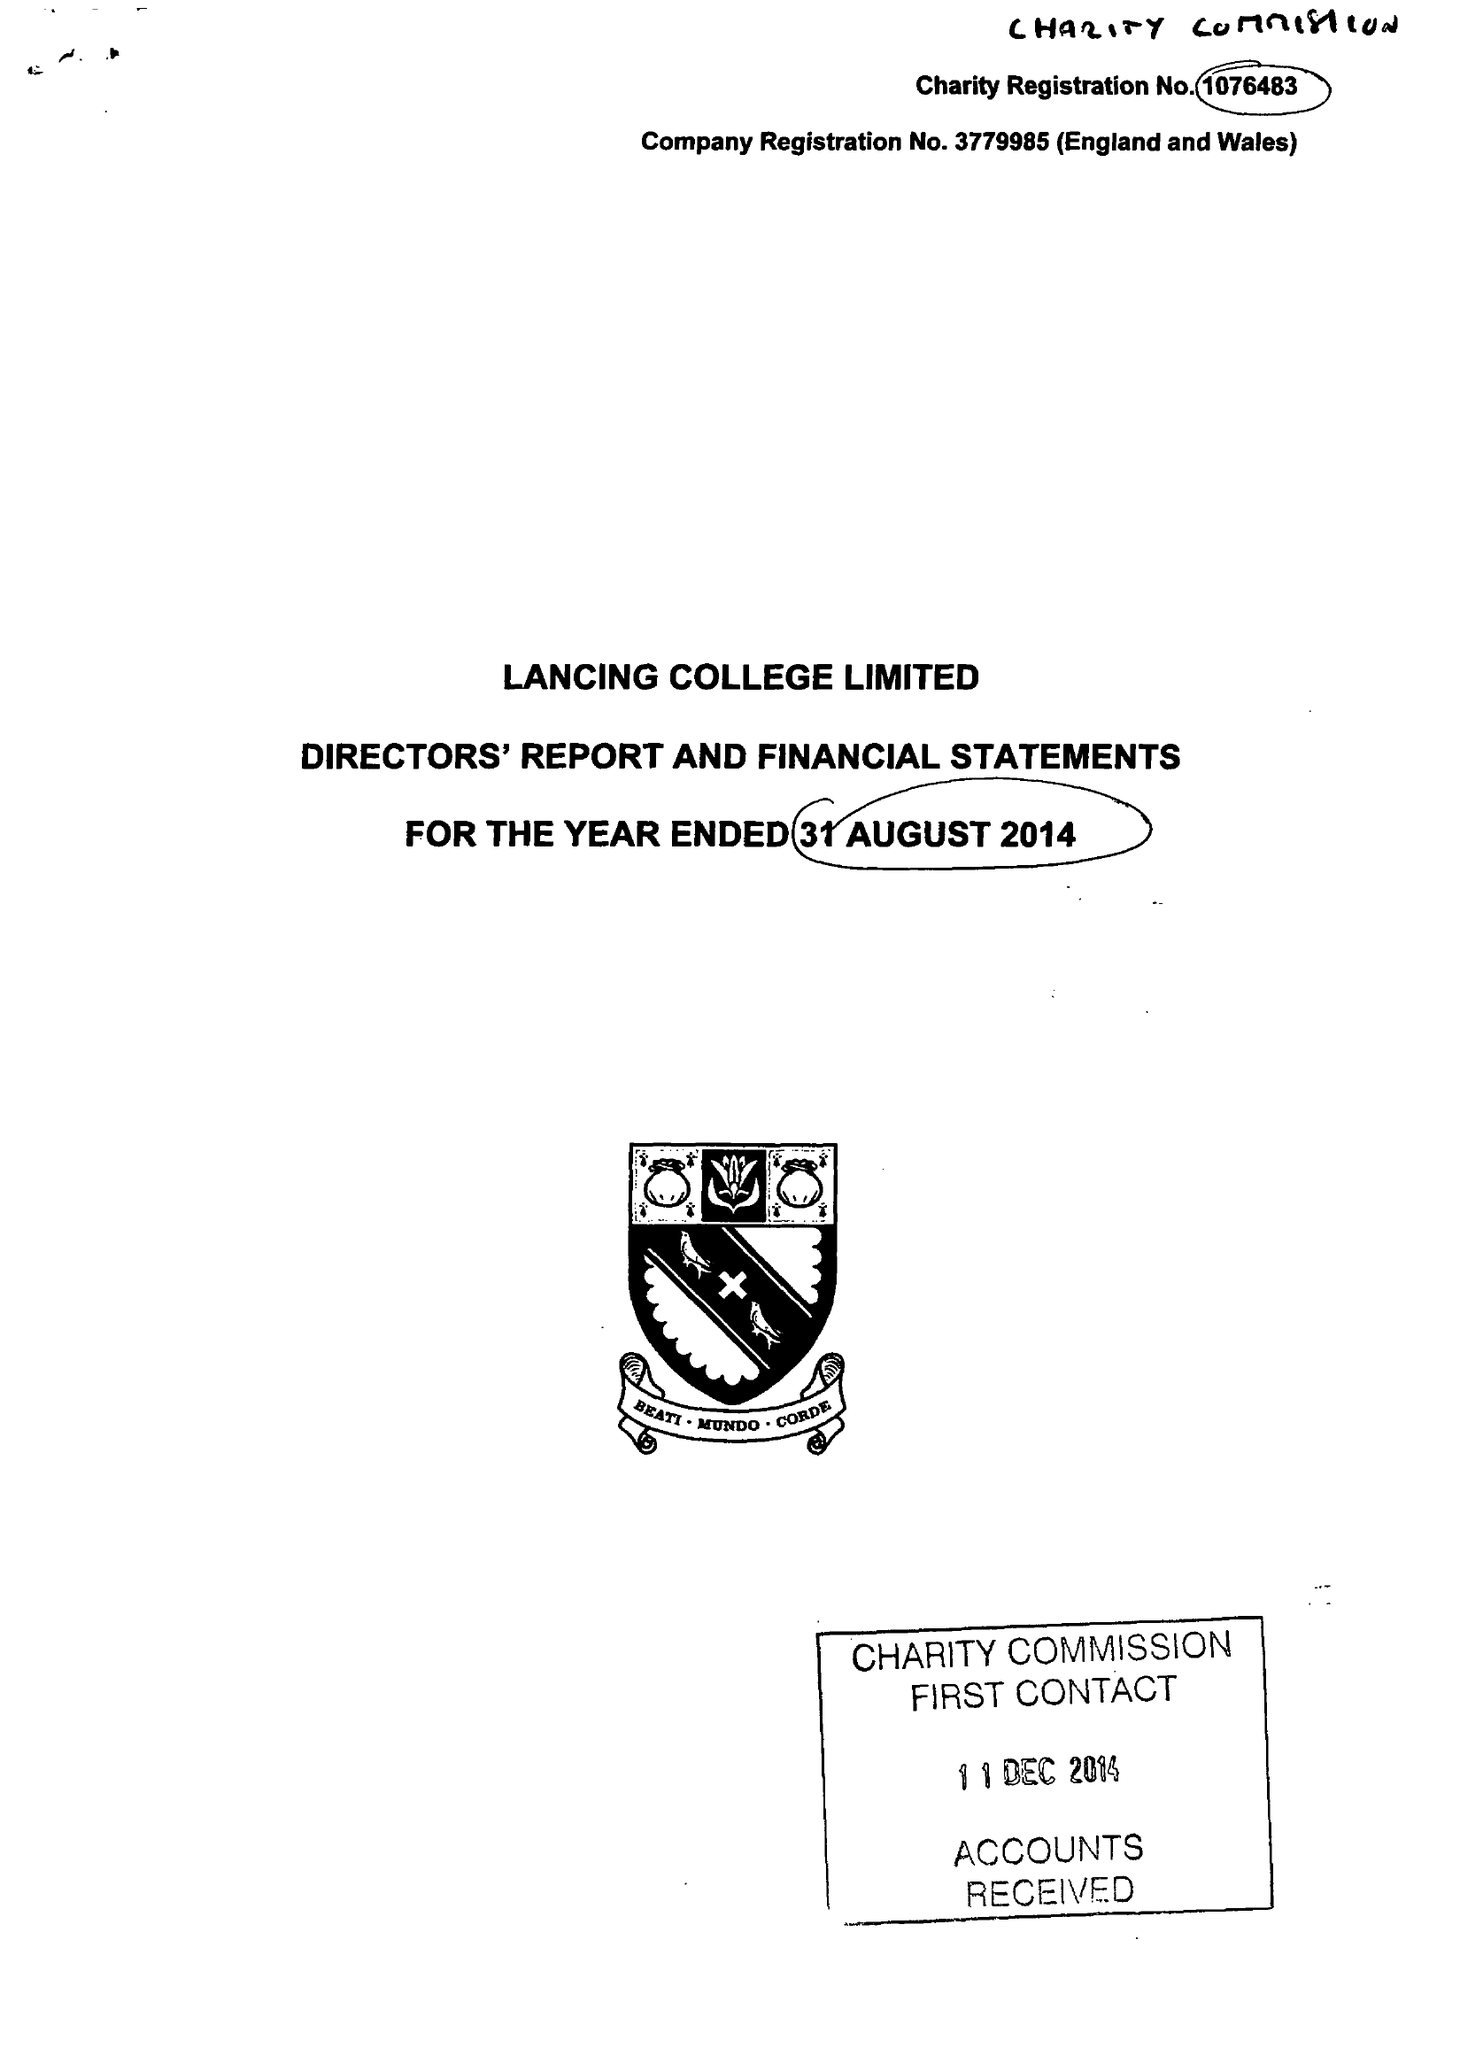What is the value for the spending_annually_in_british_pounds?
Answer the question using a single word or phrase. 18005373.00 